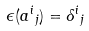Convert formula to latex. <formula><loc_0><loc_0><loc_500><loc_500>\epsilon ( { a ^ { i } } _ { j } ) = \delta { ^ { i } } _ { j }</formula> 